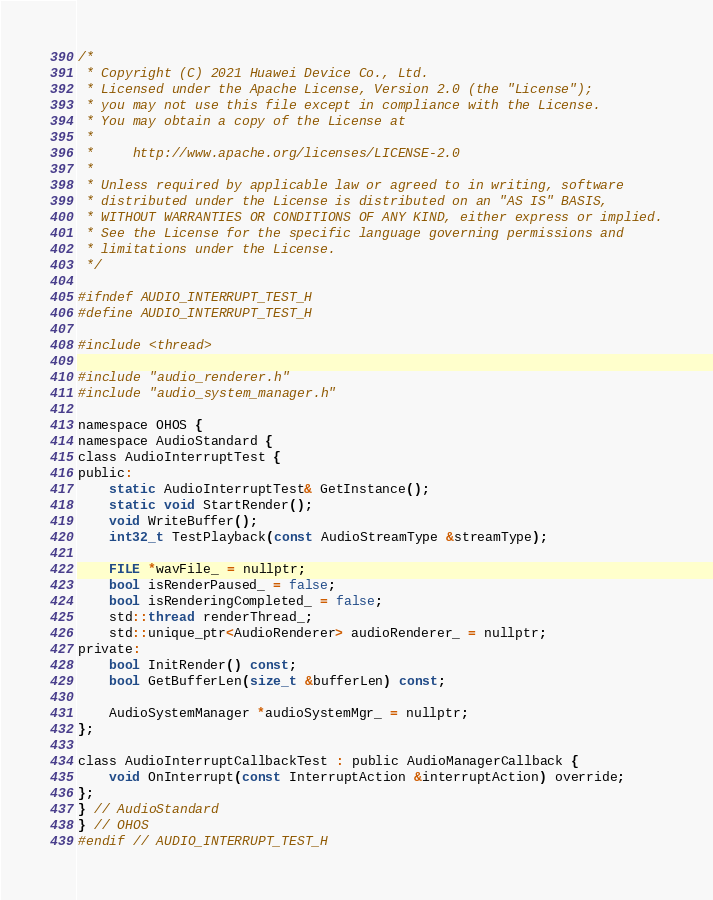<code> <loc_0><loc_0><loc_500><loc_500><_C_>/*
 * Copyright (C) 2021 Huawei Device Co., Ltd.
 * Licensed under the Apache License, Version 2.0 (the "License");
 * you may not use this file except in compliance with the License.
 * You may obtain a copy of the License at
 *
 *     http://www.apache.org/licenses/LICENSE-2.0
 *
 * Unless required by applicable law or agreed to in writing, software
 * distributed under the License is distributed on an "AS IS" BASIS,
 * WITHOUT WARRANTIES OR CONDITIONS OF ANY KIND, either express or implied.
 * See the License for the specific language governing permissions and
 * limitations under the License.
 */

#ifndef AUDIO_INTERRUPT_TEST_H
#define AUDIO_INTERRUPT_TEST_H

#include <thread>

#include "audio_renderer.h"
#include "audio_system_manager.h"

namespace OHOS {
namespace AudioStandard {
class AudioInterruptTest {
public:
    static AudioInterruptTest& GetInstance();
    static void StartRender();
    void WriteBuffer();
    int32_t TestPlayback(const AudioStreamType &streamType);

    FILE *wavFile_ = nullptr;
    bool isRenderPaused_ = false;
    bool isRenderingCompleted_ = false;
    std::thread renderThread_;
    std::unique_ptr<AudioRenderer> audioRenderer_ = nullptr;
private:
    bool InitRender() const;
    bool GetBufferLen(size_t &bufferLen) const;

    AudioSystemManager *audioSystemMgr_ = nullptr;
};

class AudioInterruptCallbackTest : public AudioManagerCallback {
    void OnInterrupt(const InterruptAction &interruptAction) override;
};
} // AudioStandard
} // OHOS
#endif // AUDIO_INTERRUPT_TEST_H</code> 